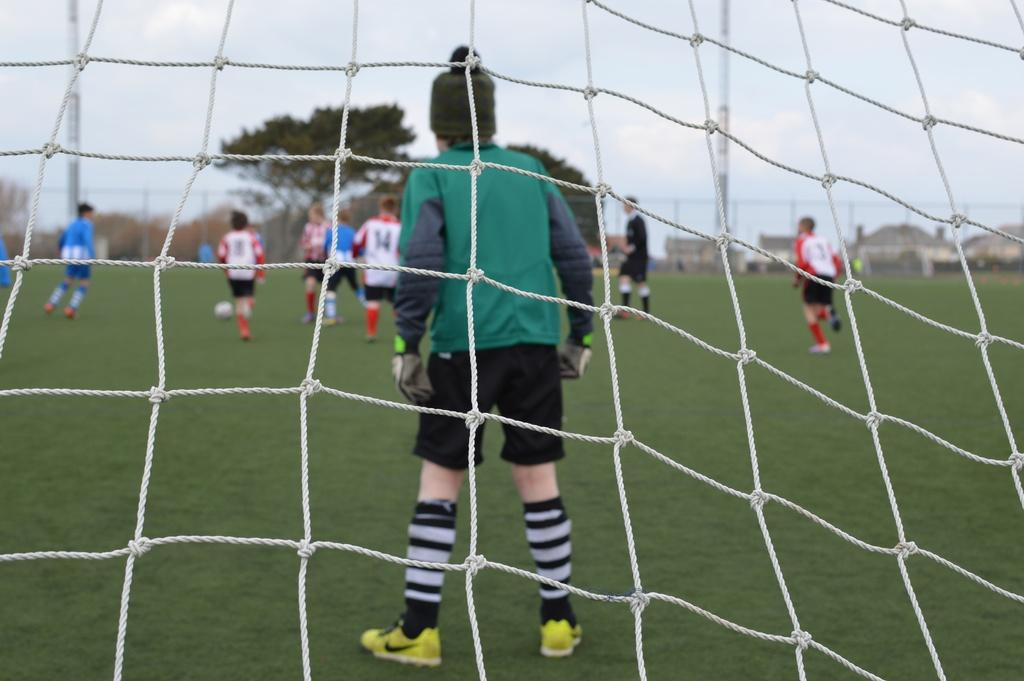<image>
Write a terse but informative summary of the picture. Soccer field of player behind the goal looking at number fourteen. 